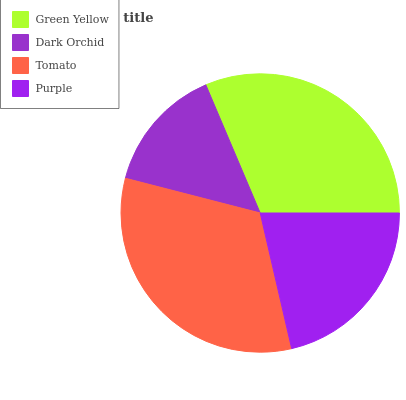Is Dark Orchid the minimum?
Answer yes or no. Yes. Is Tomato the maximum?
Answer yes or no. Yes. Is Tomato the minimum?
Answer yes or no. No. Is Dark Orchid the maximum?
Answer yes or no. No. Is Tomato greater than Dark Orchid?
Answer yes or no. Yes. Is Dark Orchid less than Tomato?
Answer yes or no. Yes. Is Dark Orchid greater than Tomato?
Answer yes or no. No. Is Tomato less than Dark Orchid?
Answer yes or no. No. Is Green Yellow the high median?
Answer yes or no. Yes. Is Purple the low median?
Answer yes or no. Yes. Is Tomato the high median?
Answer yes or no. No. Is Green Yellow the low median?
Answer yes or no. No. 